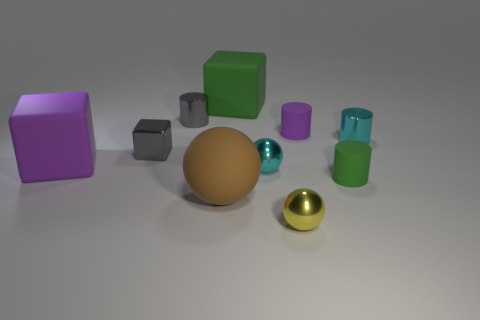Describe the surface on which the objects are placed. The objects are situated on a flat surface that appears to have a matte finish. The lighting suggests the surface may be slightly reflective, as evidenced by the soft shadows and gentle highlights on the objects, as well as the subtle reflection of the sphere. 